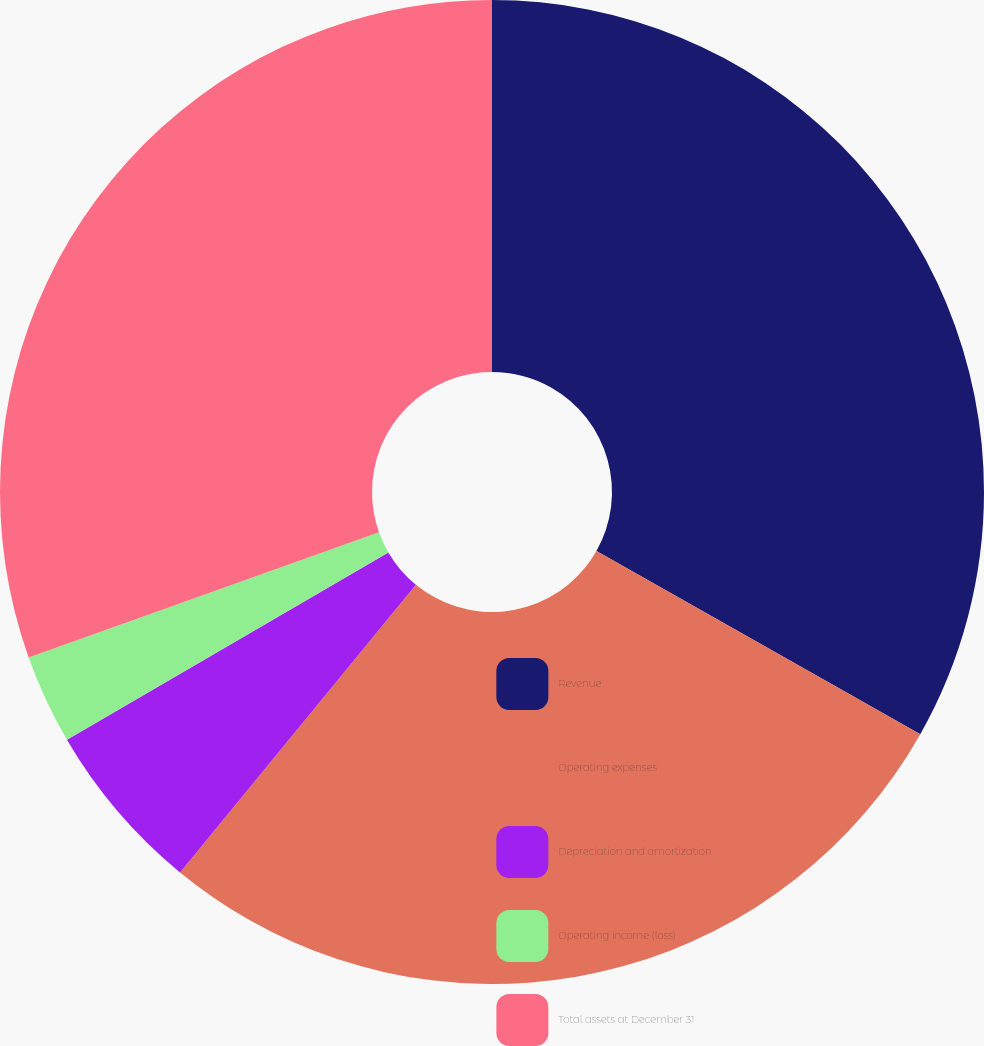Convert chart to OTSL. <chart><loc_0><loc_0><loc_500><loc_500><pie_chart><fcel>Revenue<fcel>Operating expenses<fcel>Depreciation and amortization<fcel>Operating income (loss)<fcel>Total assets at December 31<nl><fcel>33.19%<fcel>27.74%<fcel>5.67%<fcel>2.94%<fcel>30.46%<nl></chart> 